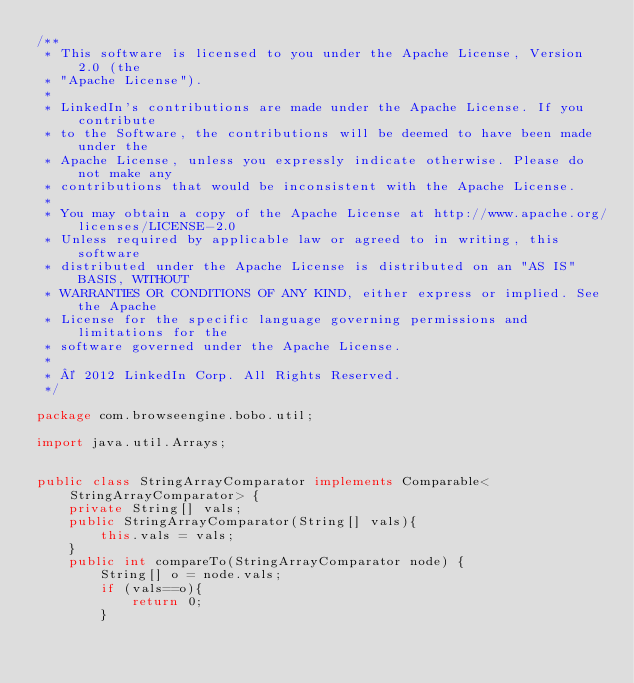Convert code to text. <code><loc_0><loc_0><loc_500><loc_500><_Java_>/**
 * This software is licensed to you under the Apache License, Version 2.0 (the
 * "Apache License").
 *
 * LinkedIn's contributions are made under the Apache License. If you contribute
 * to the Software, the contributions will be deemed to have been made under the
 * Apache License, unless you expressly indicate otherwise. Please do not make any
 * contributions that would be inconsistent with the Apache License.
 *
 * You may obtain a copy of the Apache License at http://www.apache.org/licenses/LICENSE-2.0
 * Unless required by applicable law or agreed to in writing, this software
 * distributed under the Apache License is distributed on an "AS IS" BASIS, WITHOUT
 * WARRANTIES OR CONDITIONS OF ANY KIND, either express or implied. See the Apache
 * License for the specific language governing permissions and limitations for the
 * software governed under the Apache License.
 *
 * © 2012 LinkedIn Corp. All Rights Reserved.  
 */

package com.browseengine.bobo.util;

import java.util.Arrays;


public class StringArrayComparator implements Comparable<StringArrayComparator> {
	private String[] vals;
	public StringArrayComparator(String[] vals){
		this.vals = vals;
	}
	public int compareTo(StringArrayComparator node) {
		String[] o = node.vals;
		if (vals==o){
			return 0;
		}</code> 